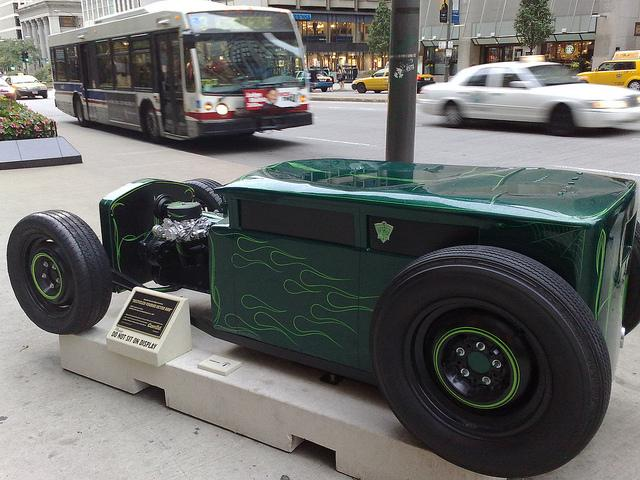Why is the car on the sidewalk?

Choices:
A) parking zone
B) accident
C) broke down
D) display display 